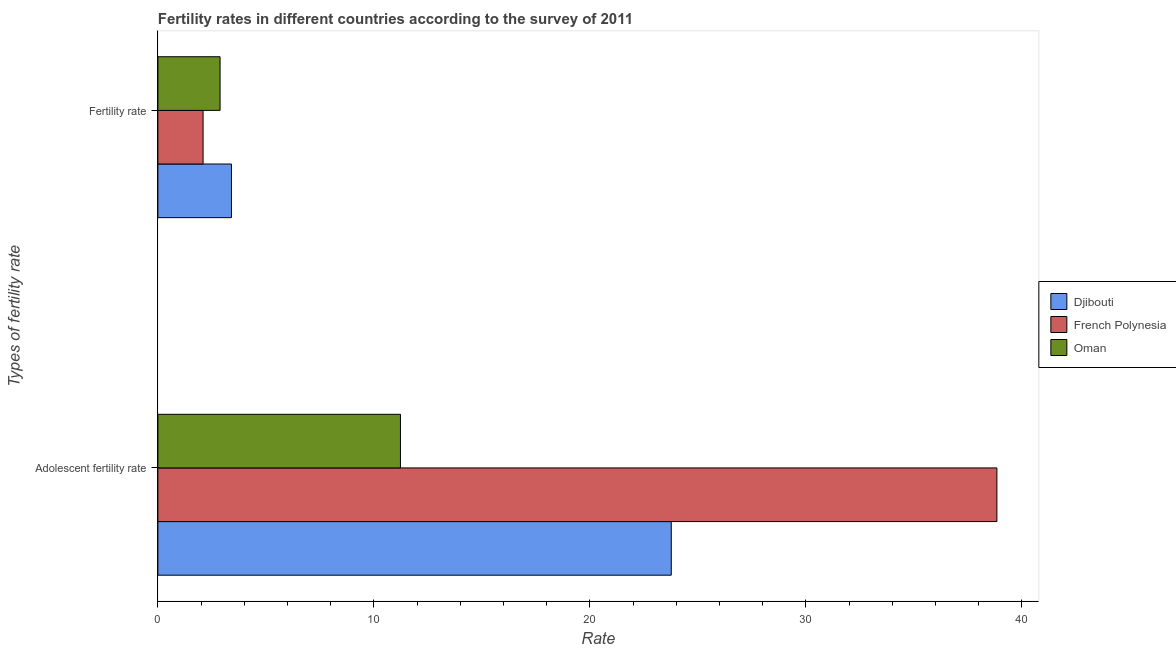Are the number of bars per tick equal to the number of legend labels?
Give a very brief answer. Yes. What is the label of the 1st group of bars from the top?
Your answer should be compact. Fertility rate. What is the adolescent fertility rate in French Polynesia?
Offer a terse response. 38.84. Across all countries, what is the maximum fertility rate?
Make the answer very short. 3.41. Across all countries, what is the minimum fertility rate?
Offer a terse response. 2.09. In which country was the adolescent fertility rate maximum?
Ensure brevity in your answer.  French Polynesia. In which country was the fertility rate minimum?
Your answer should be compact. French Polynesia. What is the total fertility rate in the graph?
Ensure brevity in your answer.  8.38. What is the difference between the adolescent fertility rate in Oman and that in Djibouti?
Offer a very short reply. -12.54. What is the difference between the fertility rate in Djibouti and the adolescent fertility rate in French Polynesia?
Your answer should be compact. -35.44. What is the average adolescent fertility rate per country?
Keep it short and to the point. 24.61. What is the difference between the fertility rate and adolescent fertility rate in French Polynesia?
Your answer should be very brief. -36.75. What is the ratio of the fertility rate in Djibouti to that in French Polynesia?
Keep it short and to the point. 1.63. What does the 2nd bar from the top in Fertility rate represents?
Offer a terse response. French Polynesia. What does the 2nd bar from the bottom in Adolescent fertility rate represents?
Provide a succinct answer. French Polynesia. How many bars are there?
Offer a very short reply. 6. Does the graph contain any zero values?
Make the answer very short. No. Does the graph contain grids?
Offer a terse response. No. Where does the legend appear in the graph?
Your answer should be very brief. Center right. How many legend labels are there?
Provide a succinct answer. 3. How are the legend labels stacked?
Offer a very short reply. Vertical. What is the title of the graph?
Your response must be concise. Fertility rates in different countries according to the survey of 2011. Does "Turkmenistan" appear as one of the legend labels in the graph?
Keep it short and to the point. No. What is the label or title of the X-axis?
Your response must be concise. Rate. What is the label or title of the Y-axis?
Offer a very short reply. Types of fertility rate. What is the Rate in Djibouti in Adolescent fertility rate?
Your response must be concise. 23.77. What is the Rate in French Polynesia in Adolescent fertility rate?
Keep it short and to the point. 38.84. What is the Rate of Oman in Adolescent fertility rate?
Ensure brevity in your answer.  11.23. What is the Rate in Djibouti in Fertility rate?
Give a very brief answer. 3.41. What is the Rate of French Polynesia in Fertility rate?
Provide a short and direct response. 2.09. What is the Rate of Oman in Fertility rate?
Your response must be concise. 2.88. Across all Types of fertility rate, what is the maximum Rate in Djibouti?
Offer a very short reply. 23.77. Across all Types of fertility rate, what is the maximum Rate in French Polynesia?
Ensure brevity in your answer.  38.84. Across all Types of fertility rate, what is the maximum Rate in Oman?
Your answer should be compact. 11.23. Across all Types of fertility rate, what is the minimum Rate in Djibouti?
Your response must be concise. 3.41. Across all Types of fertility rate, what is the minimum Rate in French Polynesia?
Give a very brief answer. 2.09. Across all Types of fertility rate, what is the minimum Rate in Oman?
Offer a very short reply. 2.88. What is the total Rate in Djibouti in the graph?
Ensure brevity in your answer.  27.17. What is the total Rate in French Polynesia in the graph?
Provide a short and direct response. 40.93. What is the total Rate of Oman in the graph?
Ensure brevity in your answer.  14.11. What is the difference between the Rate of Djibouti in Adolescent fertility rate and that in Fertility rate?
Provide a short and direct response. 20.36. What is the difference between the Rate in French Polynesia in Adolescent fertility rate and that in Fertility rate?
Offer a terse response. 36.75. What is the difference between the Rate of Oman in Adolescent fertility rate and that in Fertility rate?
Your answer should be very brief. 8.35. What is the difference between the Rate in Djibouti in Adolescent fertility rate and the Rate in French Polynesia in Fertility rate?
Make the answer very short. 21.67. What is the difference between the Rate in Djibouti in Adolescent fertility rate and the Rate in Oman in Fertility rate?
Offer a terse response. 20.89. What is the difference between the Rate in French Polynesia in Adolescent fertility rate and the Rate in Oman in Fertility rate?
Give a very brief answer. 35.96. What is the average Rate of Djibouti per Types of fertility rate?
Your answer should be very brief. 13.59. What is the average Rate in French Polynesia per Types of fertility rate?
Ensure brevity in your answer.  20.47. What is the average Rate in Oman per Types of fertility rate?
Your response must be concise. 7.05. What is the difference between the Rate in Djibouti and Rate in French Polynesia in Adolescent fertility rate?
Offer a terse response. -15.07. What is the difference between the Rate in Djibouti and Rate in Oman in Adolescent fertility rate?
Offer a very short reply. 12.54. What is the difference between the Rate in French Polynesia and Rate in Oman in Adolescent fertility rate?
Offer a terse response. 27.61. What is the difference between the Rate of Djibouti and Rate of French Polynesia in Fertility rate?
Offer a terse response. 1.31. What is the difference between the Rate of Djibouti and Rate of Oman in Fertility rate?
Make the answer very short. 0.53. What is the difference between the Rate in French Polynesia and Rate in Oman in Fertility rate?
Offer a very short reply. -0.79. What is the ratio of the Rate in Djibouti in Adolescent fertility rate to that in Fertility rate?
Your response must be concise. 6.98. What is the ratio of the Rate of French Polynesia in Adolescent fertility rate to that in Fertility rate?
Your answer should be compact. 18.57. What is the ratio of the Rate of Oman in Adolescent fertility rate to that in Fertility rate?
Offer a very short reply. 3.9. What is the difference between the highest and the second highest Rate of Djibouti?
Your response must be concise. 20.36. What is the difference between the highest and the second highest Rate in French Polynesia?
Give a very brief answer. 36.75. What is the difference between the highest and the second highest Rate of Oman?
Your answer should be compact. 8.35. What is the difference between the highest and the lowest Rate of Djibouti?
Offer a terse response. 20.36. What is the difference between the highest and the lowest Rate in French Polynesia?
Your answer should be compact. 36.75. What is the difference between the highest and the lowest Rate of Oman?
Your response must be concise. 8.35. 